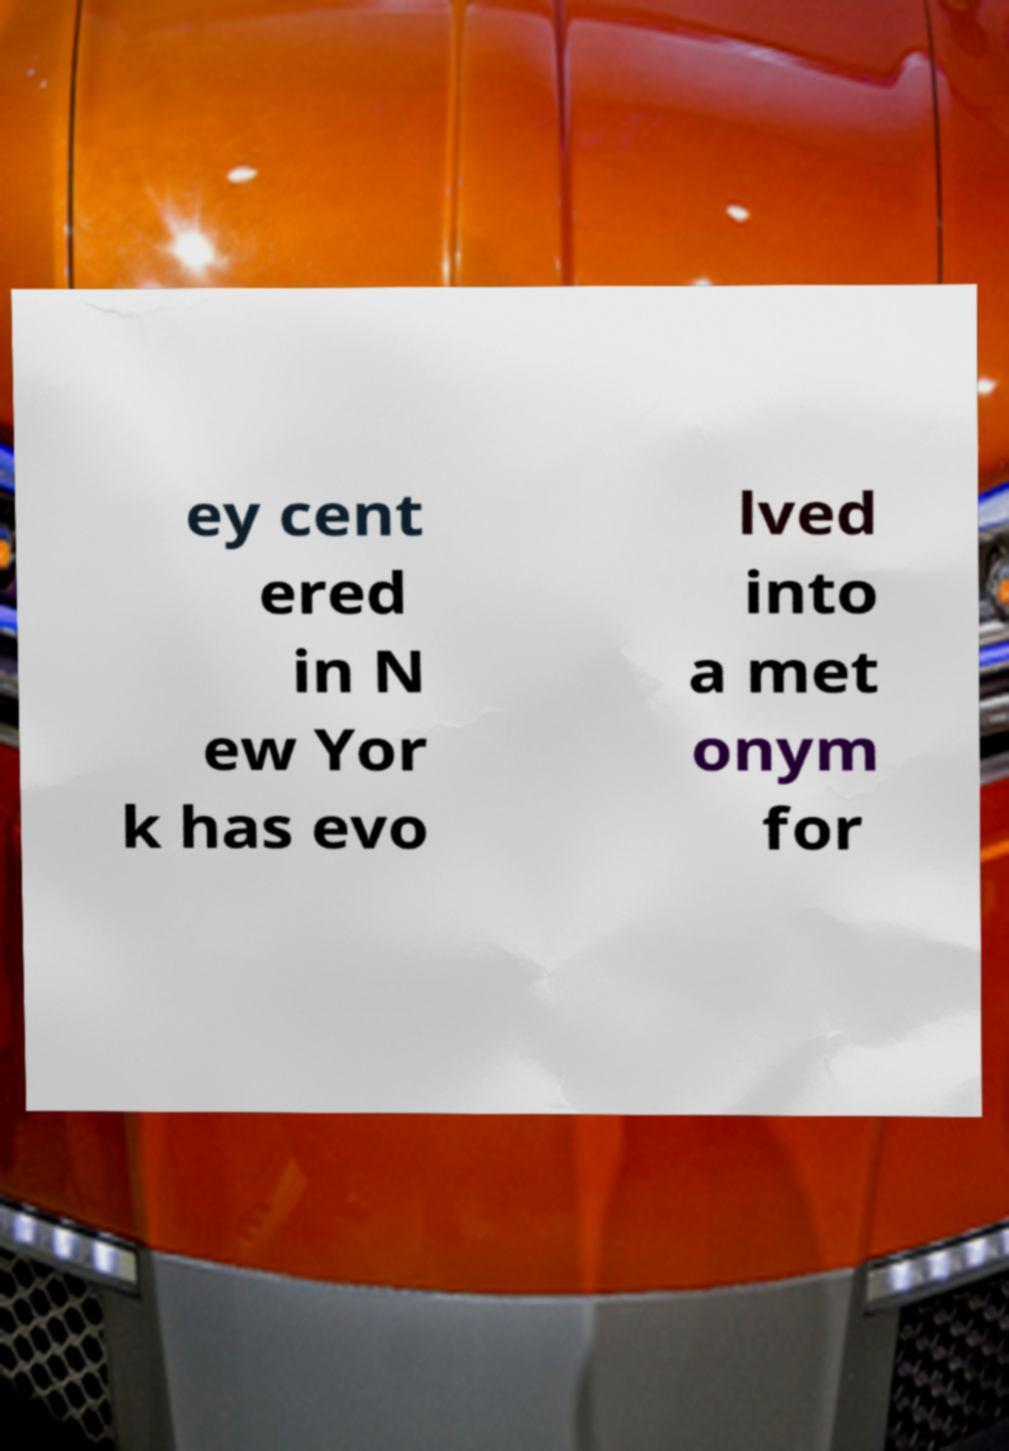Could you assist in decoding the text presented in this image and type it out clearly? ey cent ered in N ew Yor k has evo lved into a met onym for 